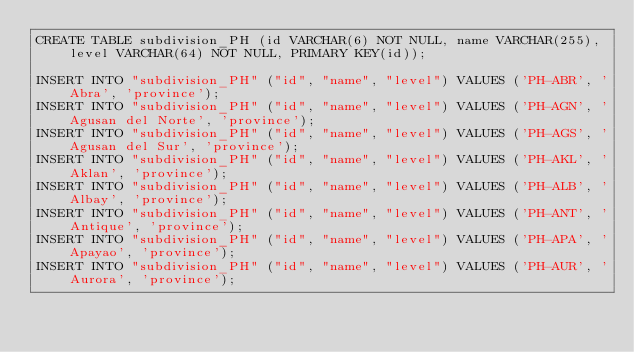Convert code to text. <code><loc_0><loc_0><loc_500><loc_500><_SQL_>CREATE TABLE subdivision_PH (id VARCHAR(6) NOT NULL, name VARCHAR(255), level VARCHAR(64) NOT NULL, PRIMARY KEY(id));

INSERT INTO "subdivision_PH" ("id", "name", "level") VALUES ('PH-ABR', 'Abra', 'province');
INSERT INTO "subdivision_PH" ("id", "name", "level") VALUES ('PH-AGN', 'Agusan del Norte', 'province');
INSERT INTO "subdivision_PH" ("id", "name", "level") VALUES ('PH-AGS', 'Agusan del Sur', 'province');
INSERT INTO "subdivision_PH" ("id", "name", "level") VALUES ('PH-AKL', 'Aklan', 'province');
INSERT INTO "subdivision_PH" ("id", "name", "level") VALUES ('PH-ALB', 'Albay', 'province');
INSERT INTO "subdivision_PH" ("id", "name", "level") VALUES ('PH-ANT', 'Antique', 'province');
INSERT INTO "subdivision_PH" ("id", "name", "level") VALUES ('PH-APA', 'Apayao', 'province');
INSERT INTO "subdivision_PH" ("id", "name", "level") VALUES ('PH-AUR', 'Aurora', 'province');</code> 